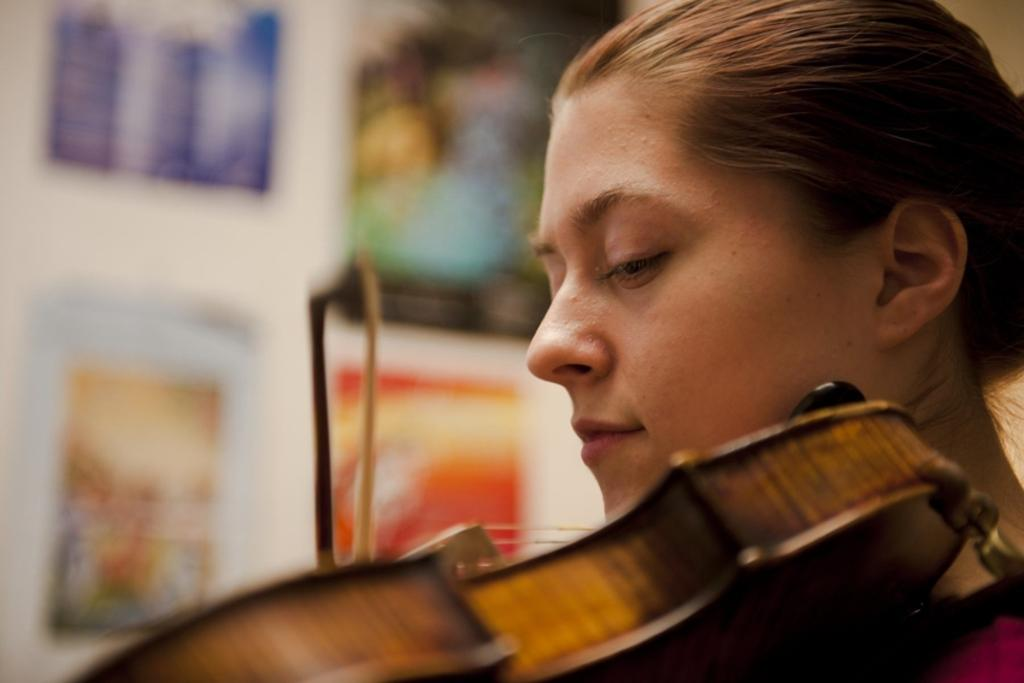Who is the main subject in the image? There is a lady in the image. What is the lady doing in the image? The lady is playing a violin. What can be seen in the background of the image? There are photo frames on the wall in the background of the image. What type of beast can be seen interacting with the lady while she plays the violin? There is no beast present in the image; the lady is playing the violin alone. What sense is being stimulated by the lady playing the violin in the image? The image does not provide information about which sense is being stimulated by the lady playing the violin. 